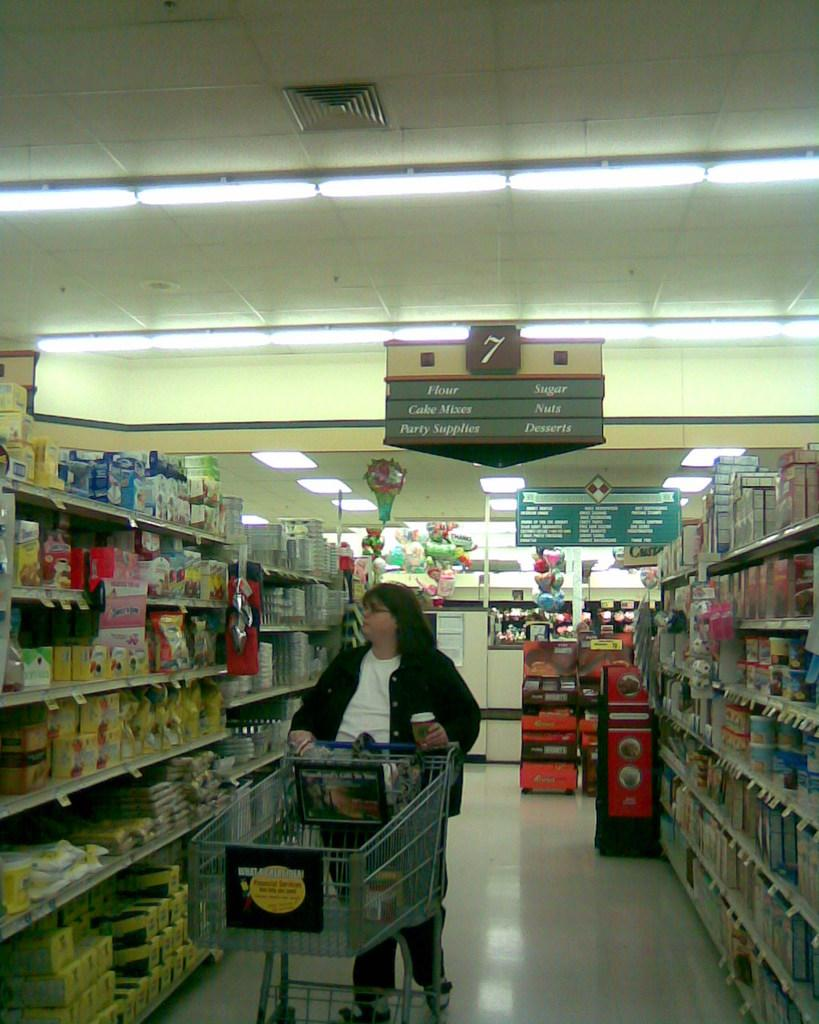<image>
Provide a brief description of the given image. a fat lady see the products displayed in the shelves of supermarket in front of 7th row with the writings of flour,cake mixes,party supplies,sugar,nuts,desserts 